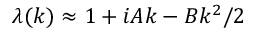Convert formula to latex. <formula><loc_0><loc_0><loc_500><loc_500>\lambda ( k ) \approx 1 + i A k - B k ^ { 2 } / 2</formula> 